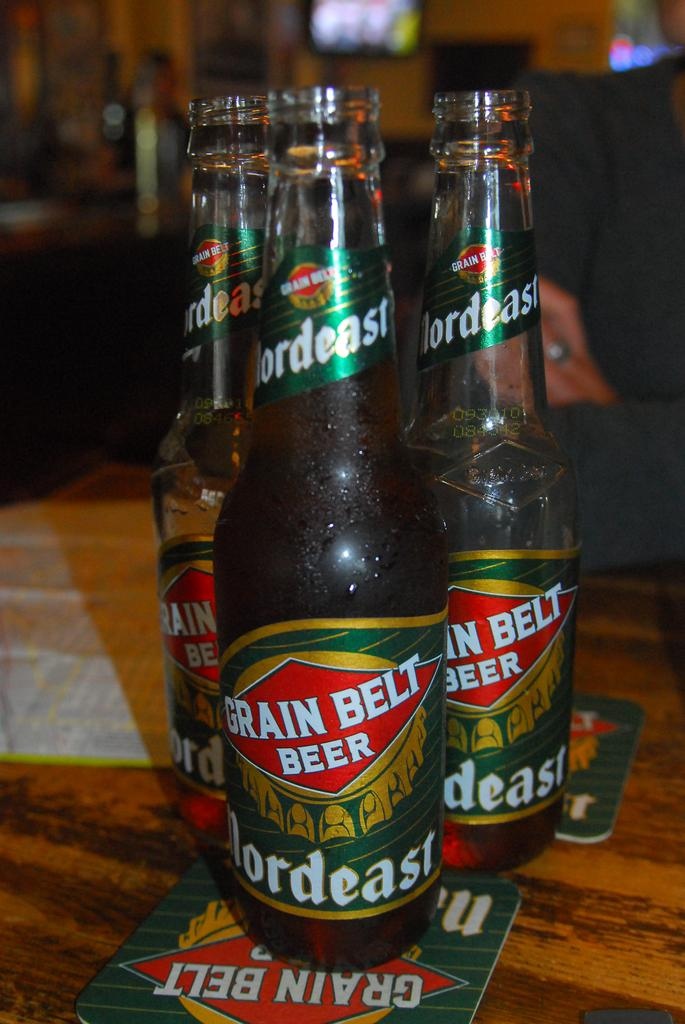What is located at the bottom of the image? There is a table at the bottom of the image. What can be seen on the table? There are three bottles placed on the table. Can you describe the man in the image? There is a man sitting in the background of the image. What type of pen is the man holding in the image? There is no pen visible in the image, and the man is not holding anything. 